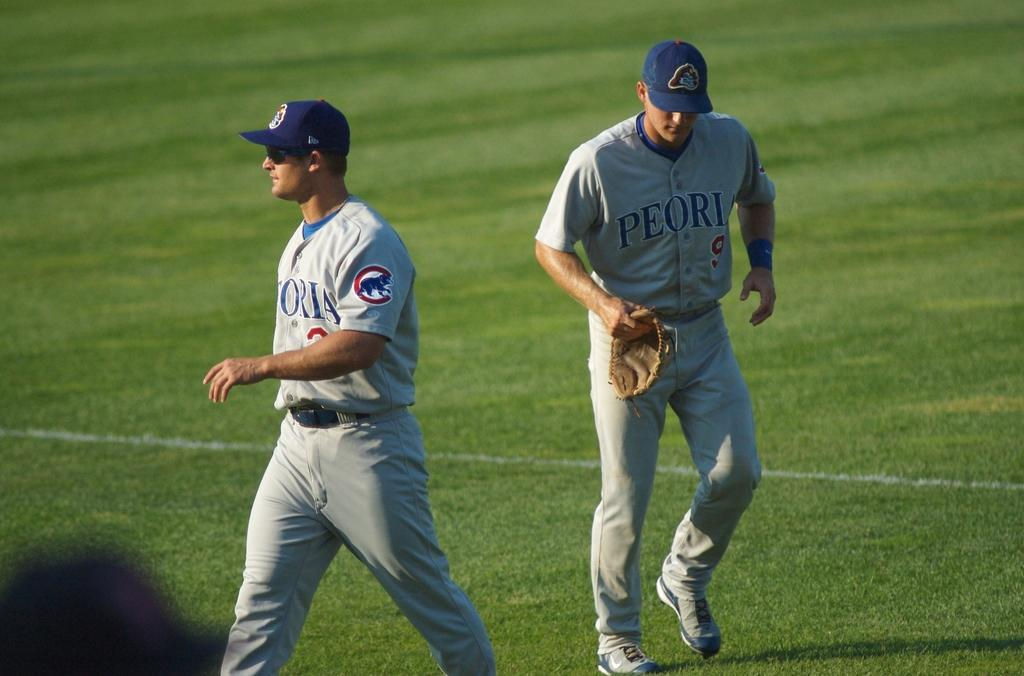<image>
Give a short and clear explanation of the subsequent image. Two players from the Peoria baseball team on the field of play. 